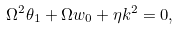<formula> <loc_0><loc_0><loc_500><loc_500>\Omega ^ { 2 } \theta _ { 1 } + \Omega w _ { 0 } + \eta k ^ { 2 } = 0 ,</formula> 